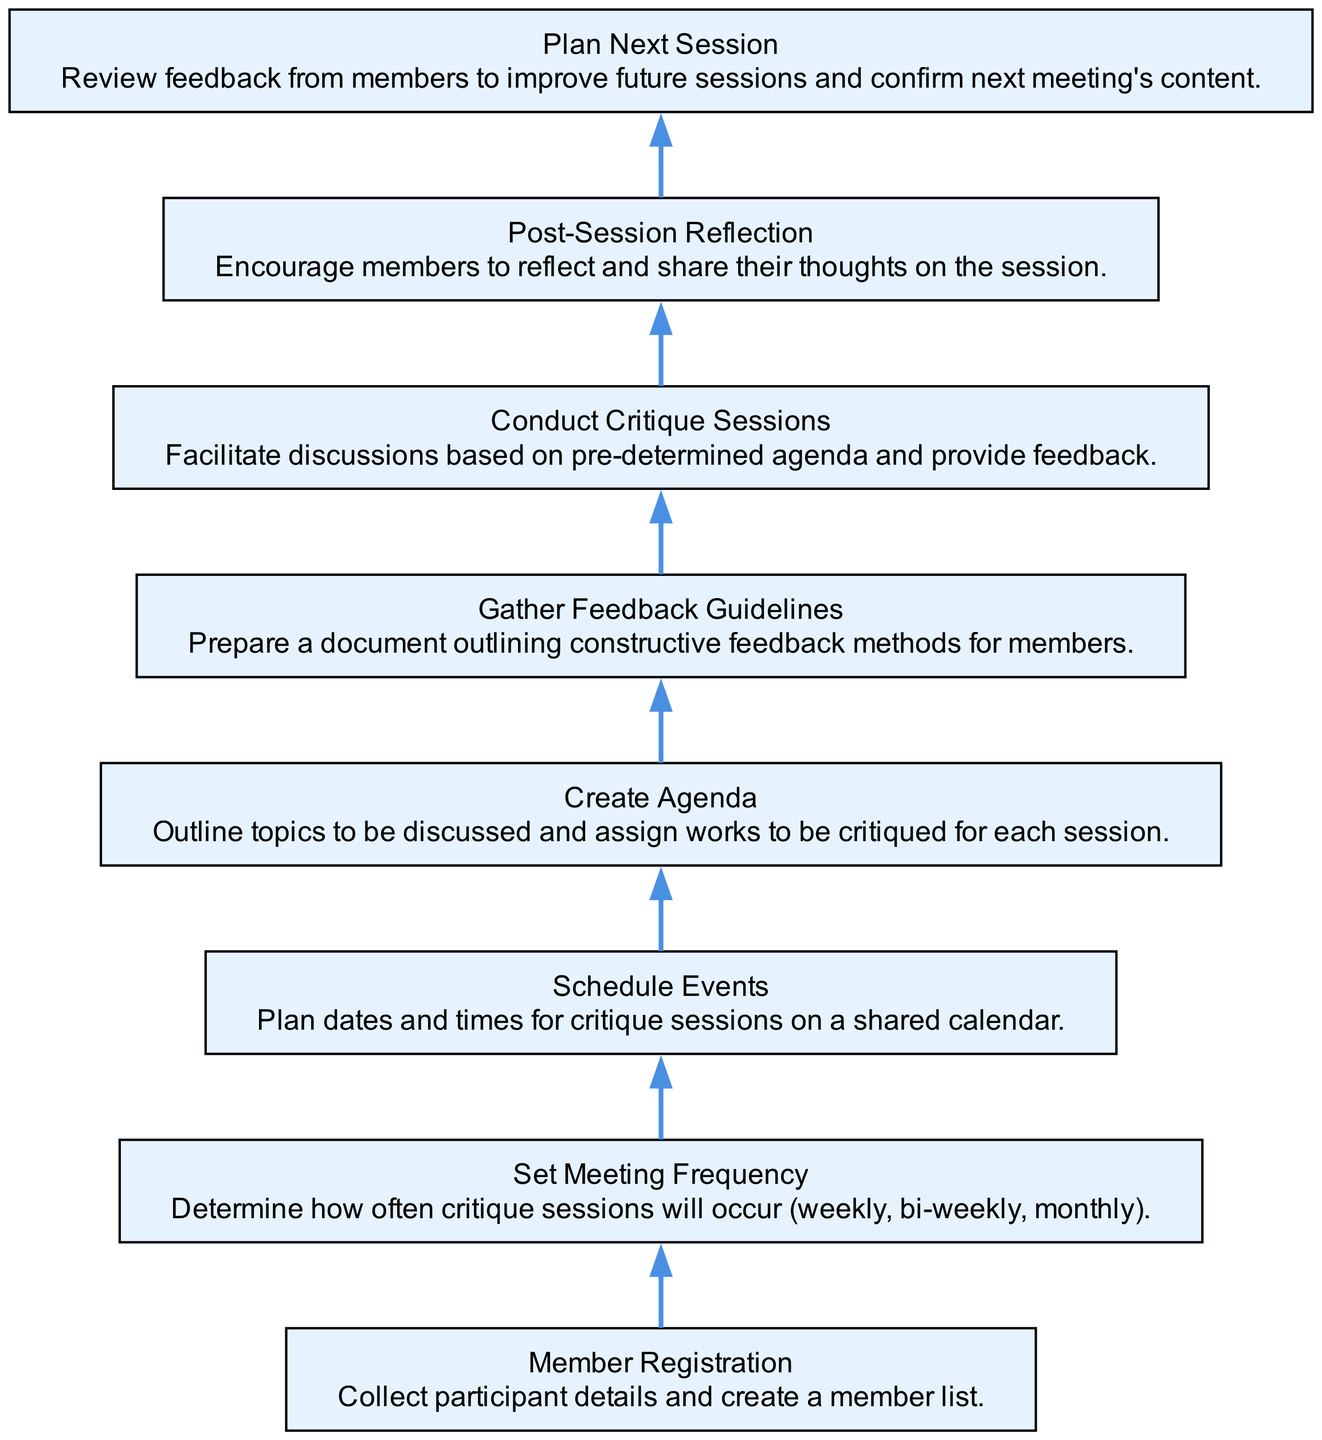What is the first step in the timeline? The first step in the timeline is "Member Registration," which involves collecting participant details and creating a member list.
Answer: Member Registration How many nodes are present in the diagram? The diagram consists of 8 nodes, each representing a different step in the writing group timeline.
Answer: 8 Which step follows "Set Meeting Frequency"? The step that follows "Set Meeting Frequency" is "Schedule Events," where dates and times for critique sessions are planned.
Answer: Schedule Events What is the last step in the flow chart? The last step in the flow chart is "Plan Next Session," which involves reviewing feedback and confirming the next meeting's content.
Answer: Plan Next Session Which steps are involved in conducting critique sessions? "Create Agenda," "Gather Feedback Guidelines," and "Conduct Critique Sessions" are the fundamental steps involved in facilitating the critique sessions effectively.
Answer: Create Agenda, Gather Feedback Guidelines, Conduct Critique Sessions What is the relationship between "Post-Session Reflection" and "Conduct Critique Sessions"? "Post-Session Reflection" occurs after "Conduct Critique Sessions," allowing members to share their thoughts following the discussion.
Answer: Post-Session Reflection occurs after Conduct Critique Sessions How many times does the "Plan Next Session" node appear in the diagram? The "Plan Next Session" node appears only once in the diagram, as it is a part of the flow sequence that leads to the conclusion of the critique process.
Answer: 1 What specific guidelines are gathered before conducting sessions? "Gather Feedback Guidelines" prepare a document outlining constructive feedback methods for session members, crucial for effective critiques.
Answer: Constructive feedback methods What is unique about this type of flow chart? This Bottom Up Flow Chart illustrates a sequential process starting from member registration and culminating in planning the next session, emphasizing the preparation stages leading up to critique events.
Answer: Sequential process 